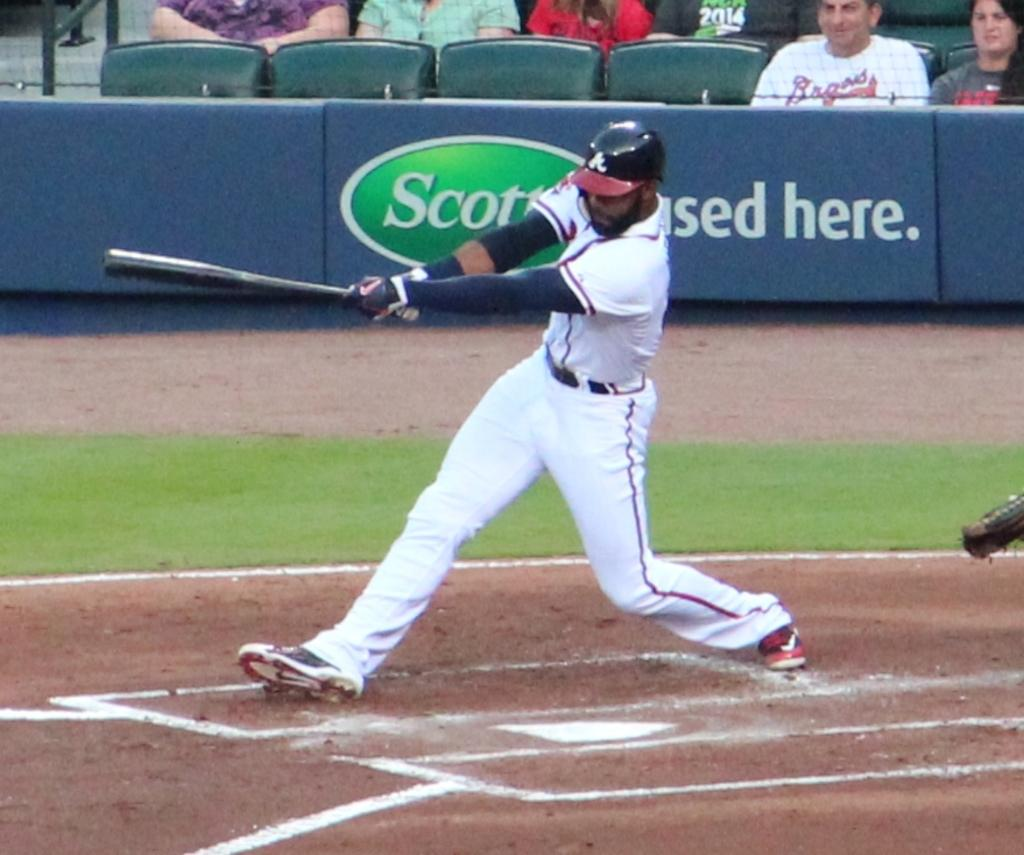<image>
Summarize the visual content of the image. A man wearing a Braves shirt watches the baseball player hit the ball. 